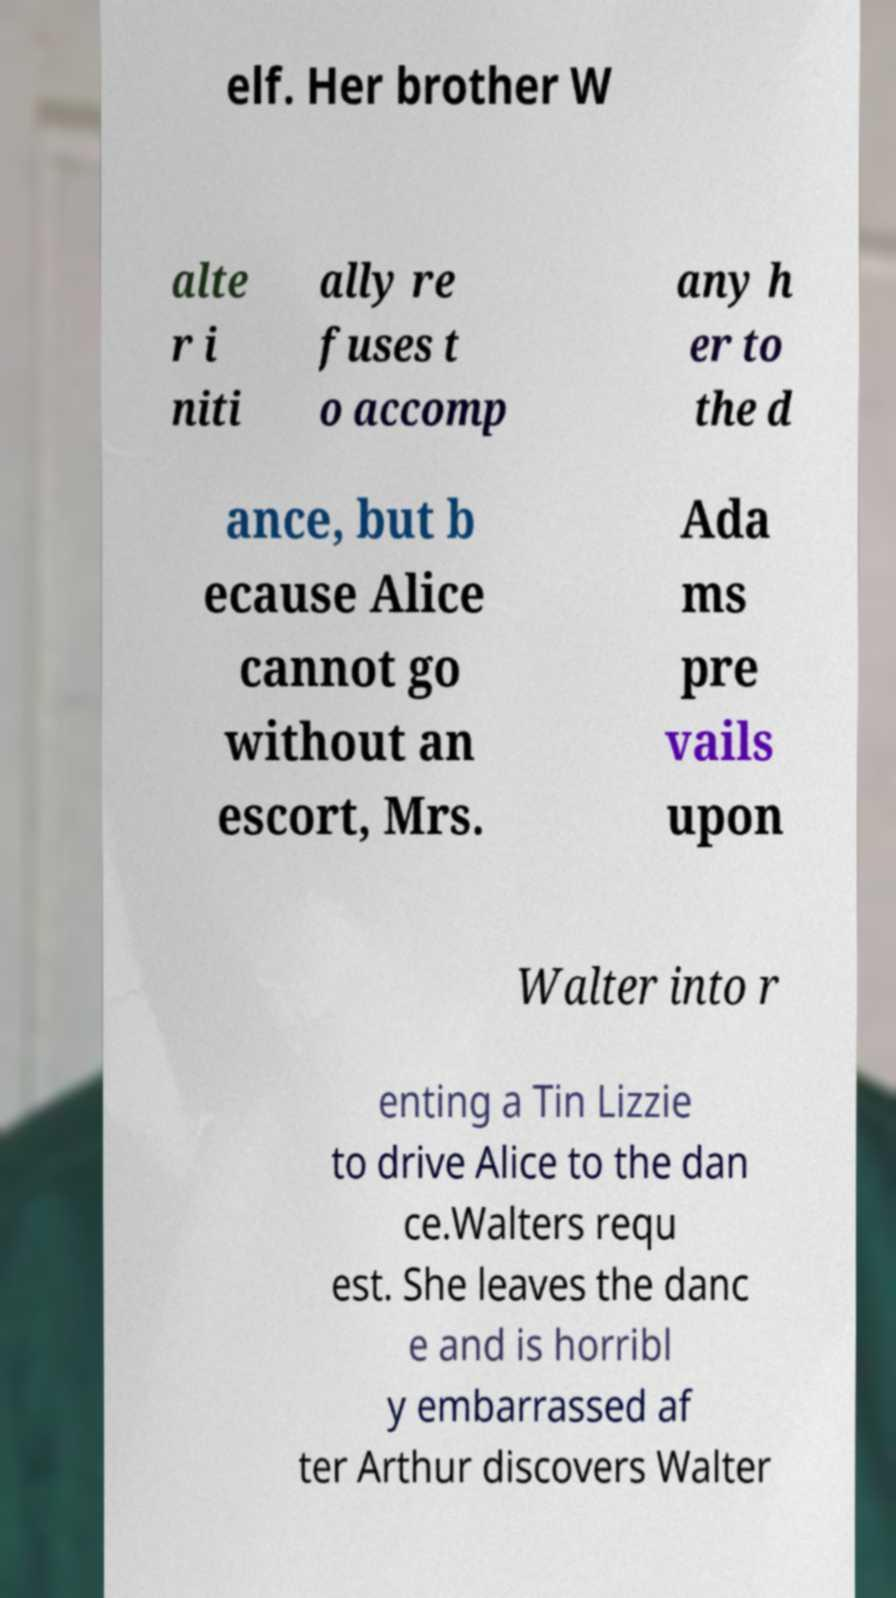Could you assist in decoding the text presented in this image and type it out clearly? elf. Her brother W alte r i niti ally re fuses t o accomp any h er to the d ance, but b ecause Alice cannot go without an escort, Mrs. Ada ms pre vails upon Walter into r enting a Tin Lizzie to drive Alice to the dan ce.Walters requ est. She leaves the danc e and is horribl y embarrassed af ter Arthur discovers Walter 